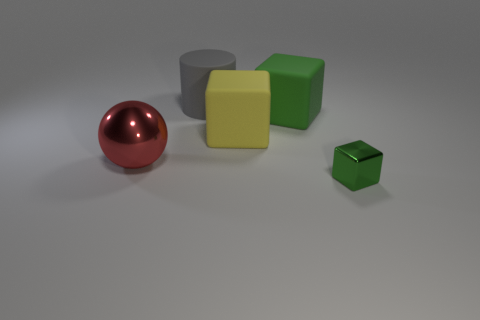How many green blocks must be subtracted to get 1 green blocks? 1 Add 4 small gray cylinders. How many objects exist? 9 Subtract all blocks. How many objects are left? 2 Add 5 red balls. How many red balls are left? 6 Add 4 objects. How many objects exist? 9 Subtract 1 gray cylinders. How many objects are left? 4 Subtract all big cubes. Subtract all small brown shiny balls. How many objects are left? 3 